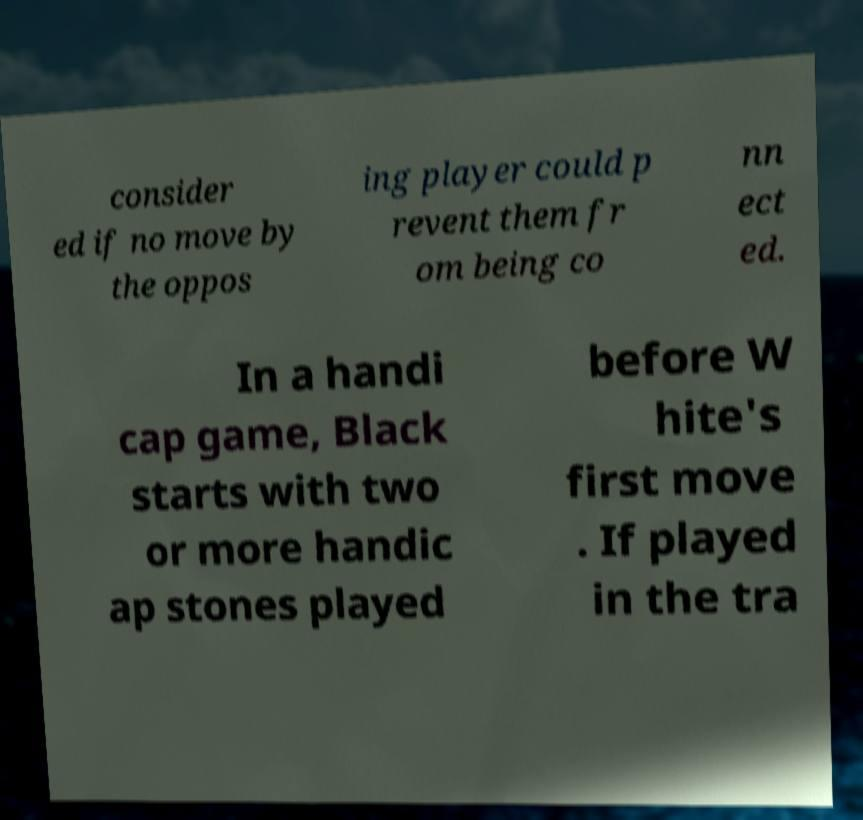Please identify and transcribe the text found in this image. consider ed if no move by the oppos ing player could p revent them fr om being co nn ect ed. In a handi cap game, Black starts with two or more handic ap stones played before W hite's first move . If played in the tra 